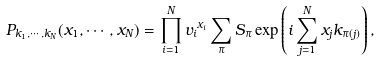Convert formula to latex. <formula><loc_0><loc_0><loc_500><loc_500>P _ { k _ { 1 } , \cdots , k _ { N } } ( x _ { 1 } , \cdots , x _ { N } ) = \prod _ { i = 1 } ^ { N } { v _ { i } } ^ { x _ { i } } \sum _ { \pi } S _ { \pi } \exp \left ( i \sum _ { j = 1 } ^ { N } x _ { j } k _ { \pi ( j ) } \right ) ,</formula> 